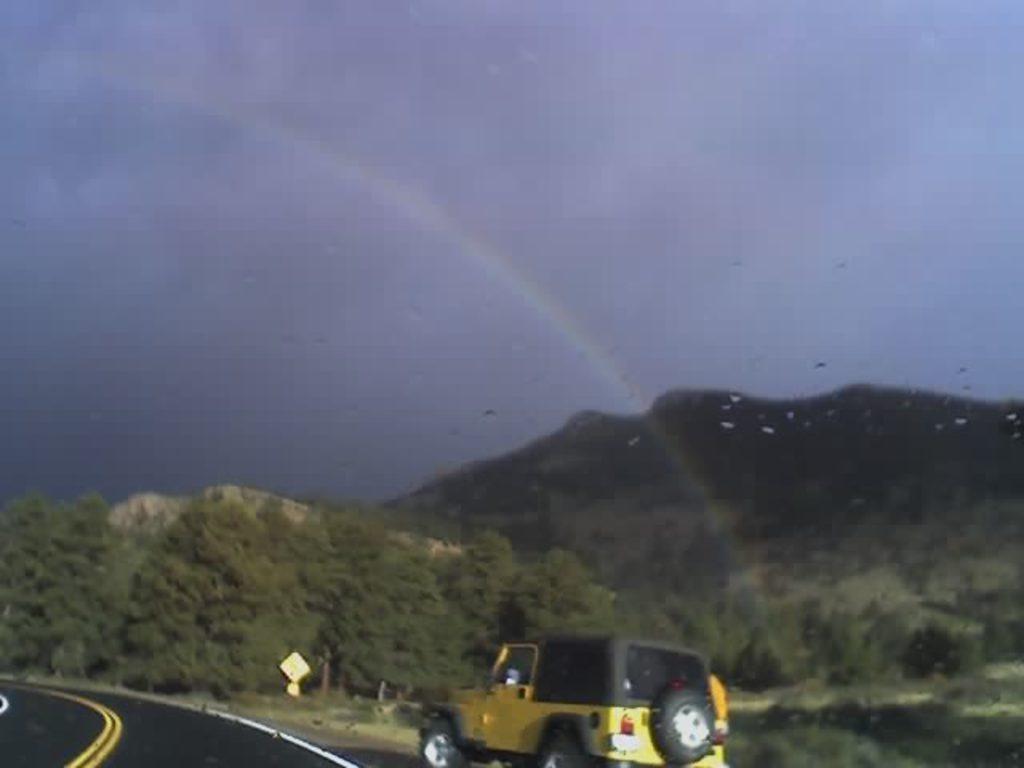Please provide a concise description of this image. In this picture we can observe a yellow color jeep moving on the road. There is yellow color board here. We can observe trees and a rainbow. In the background there is a hill and a sky. 